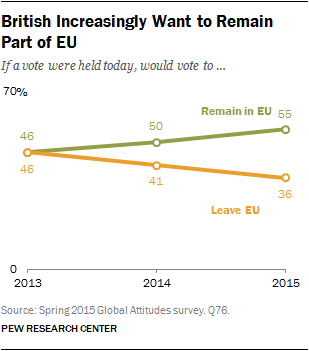Draw attention to some important aspects in this diagram. The segment "Leave EU" is colored orange. The sum and difference between those who remained in the EU and those who left in the year 2014 is unknown. 